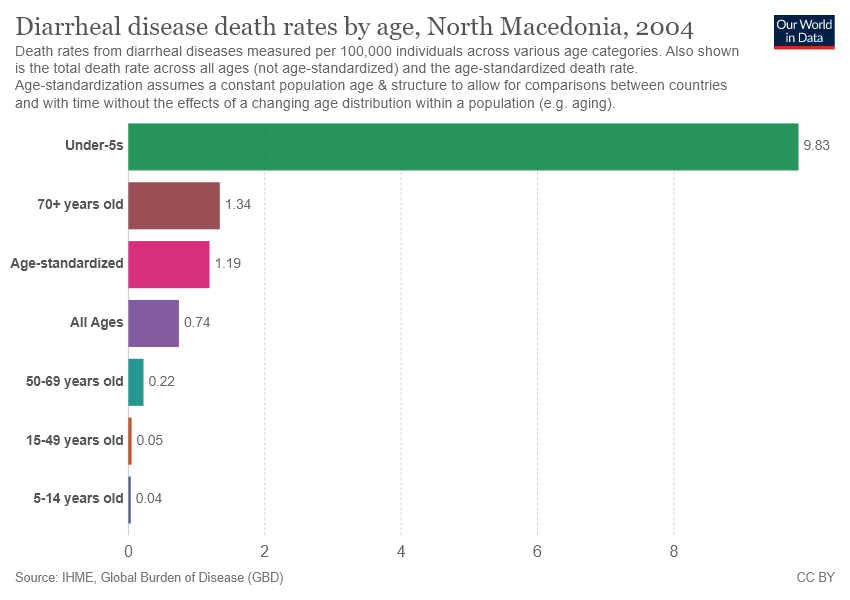What group is in the middle? The group in the middle of the graph represents the 'Age-standardized' category for diarrheal disease death rates in North Macedonia, 2004, with a rate of 1.19 deaths per 100,000 individuals. 